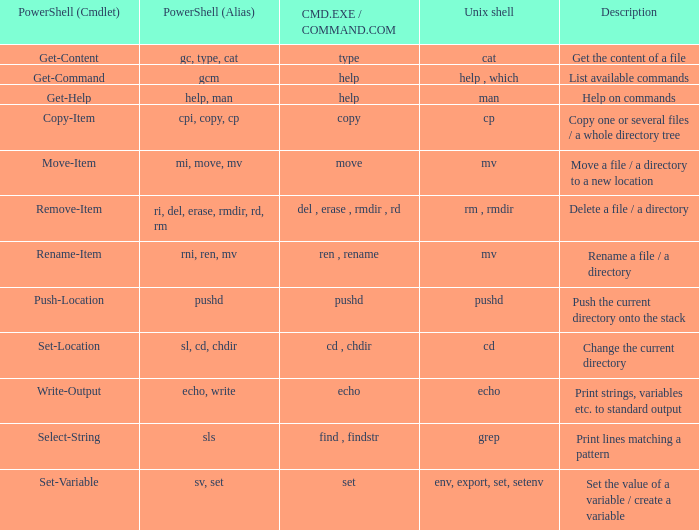How many legitimate values of powershell (cmdlet) are present when unix shell consists of env, export, set, and setenv? 1.0. 